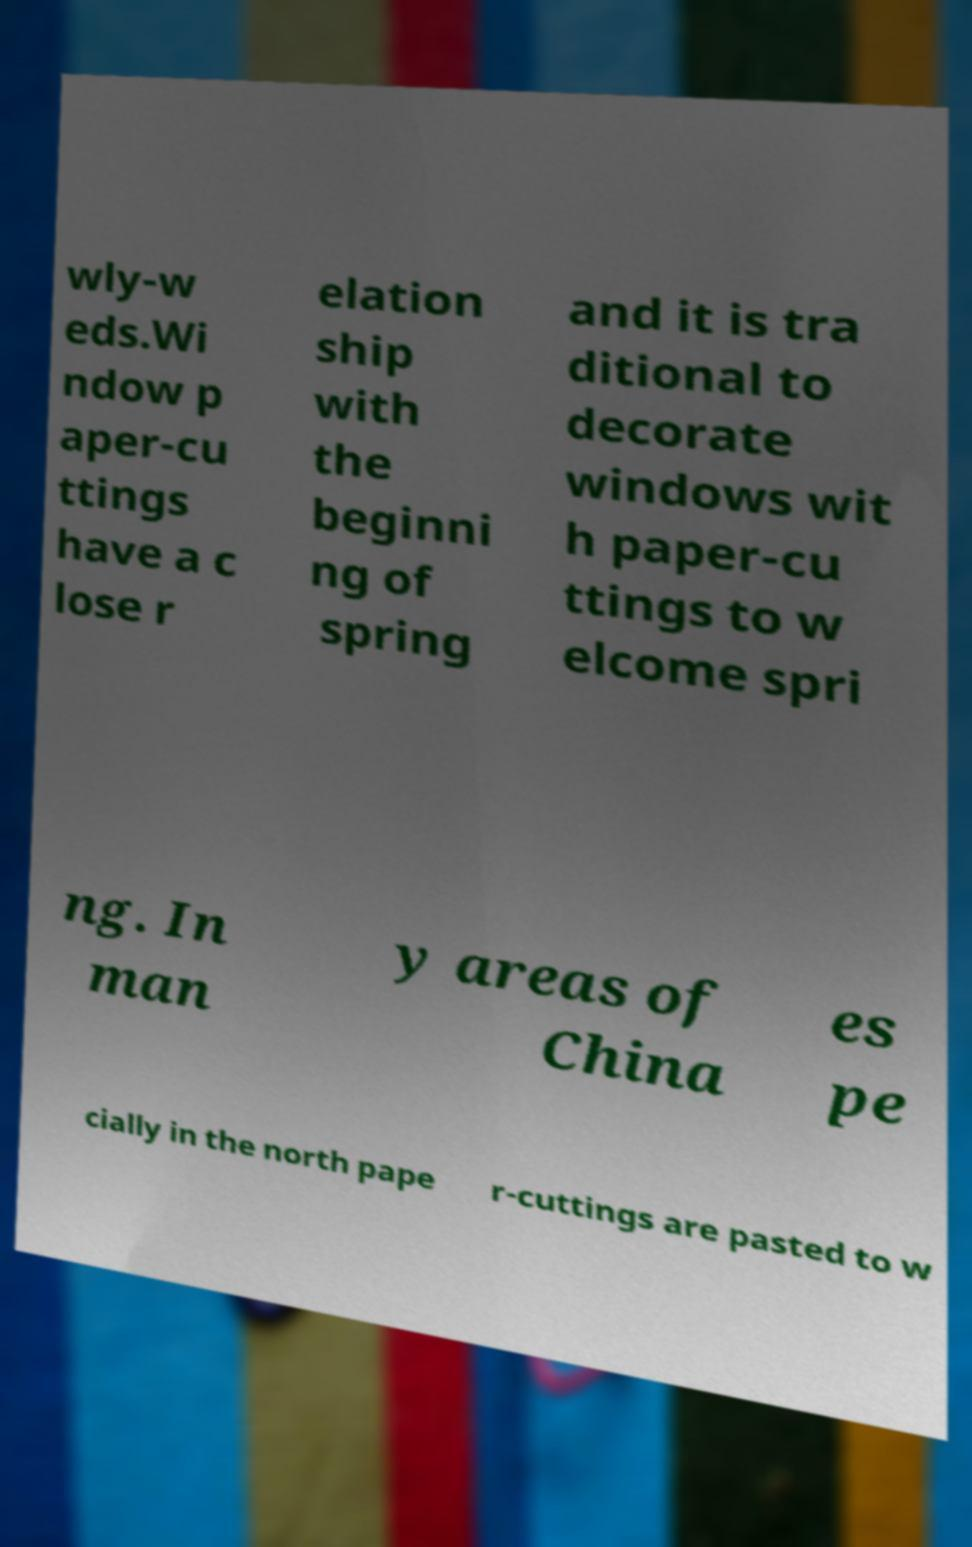Can you read and provide the text displayed in the image?This photo seems to have some interesting text. Can you extract and type it out for me? wly-w eds.Wi ndow p aper-cu ttings have a c lose r elation ship with the beginni ng of spring and it is tra ditional to decorate windows wit h paper-cu ttings to w elcome spri ng. In man y areas of China es pe cially in the north pape r-cuttings are pasted to w 